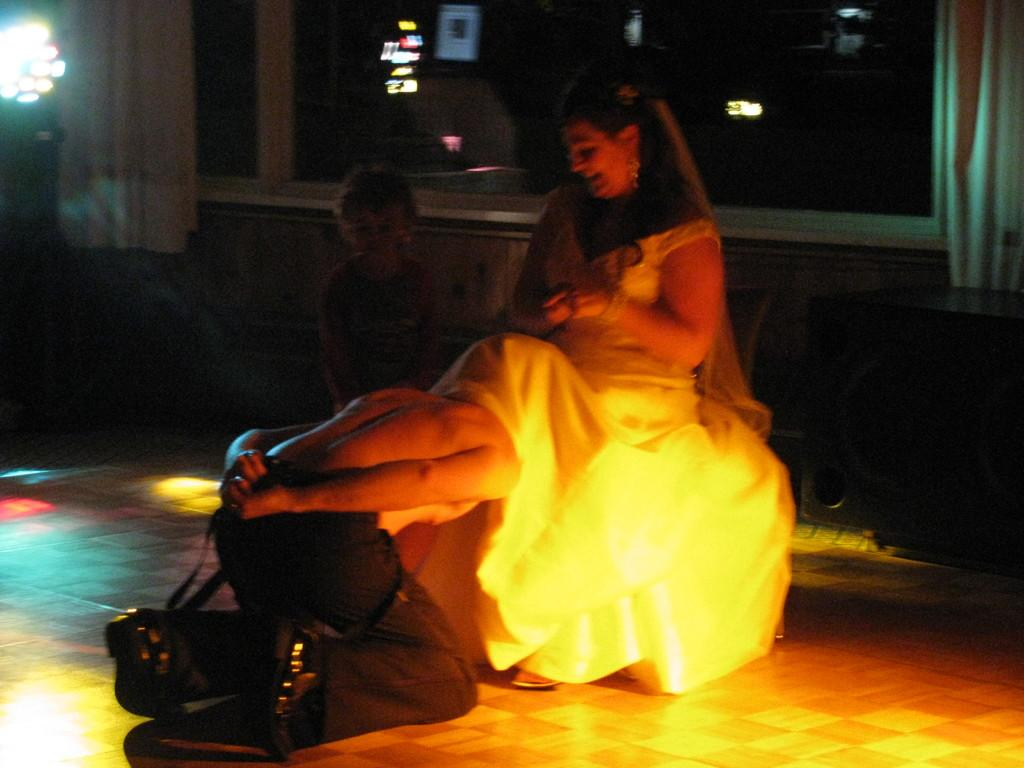What is the main subject of the image? The main subject of the image is a group of people. Can you describe the position of the woman in the image? A woman wearing a white dress is sitting on the floor. What can be seen in the background of the image? There are windows and light visible in the background of the image. What is the purpose of the slope in the image? There is no slope present in the image; it features a group of people and a woman sitting on the floor. 